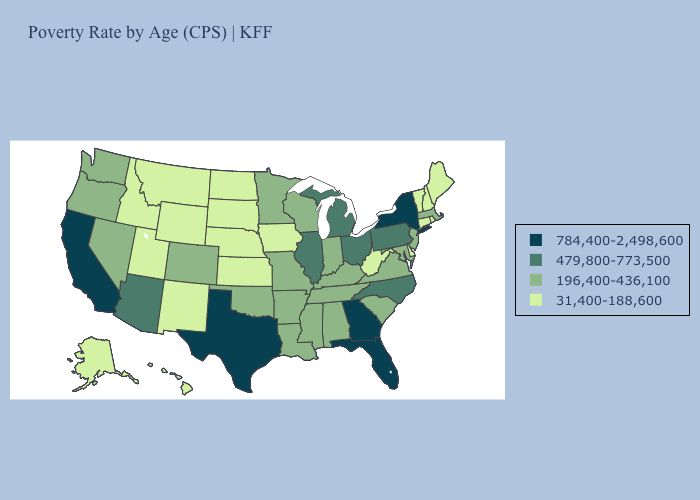Does Pennsylvania have the highest value in the USA?
Answer briefly. No. Among the states that border Massachusetts , does New York have the highest value?
Keep it brief. Yes. Does Missouri have a lower value than New Hampshire?
Short answer required. No. What is the value of Indiana?
Keep it brief. 196,400-436,100. Name the states that have a value in the range 31,400-188,600?
Keep it brief. Alaska, Connecticut, Delaware, Hawaii, Idaho, Iowa, Kansas, Maine, Montana, Nebraska, New Hampshire, New Mexico, North Dakota, Rhode Island, South Dakota, Utah, Vermont, West Virginia, Wyoming. What is the value of Mississippi?
Short answer required. 196,400-436,100. Name the states that have a value in the range 196,400-436,100?
Keep it brief. Alabama, Arkansas, Colorado, Indiana, Kentucky, Louisiana, Maryland, Massachusetts, Minnesota, Mississippi, Missouri, Nevada, New Jersey, Oklahoma, Oregon, South Carolina, Tennessee, Virginia, Washington, Wisconsin. Among the states that border Florida , which have the lowest value?
Keep it brief. Alabama. Does the map have missing data?
Concise answer only. No. Among the states that border Montana , which have the lowest value?
Answer briefly. Idaho, North Dakota, South Dakota, Wyoming. Name the states that have a value in the range 196,400-436,100?
Short answer required. Alabama, Arkansas, Colorado, Indiana, Kentucky, Louisiana, Maryland, Massachusetts, Minnesota, Mississippi, Missouri, Nevada, New Jersey, Oklahoma, Oregon, South Carolina, Tennessee, Virginia, Washington, Wisconsin. What is the highest value in states that border Alabama?
Keep it brief. 784,400-2,498,600. Among the states that border Massachusetts , does New York have the lowest value?
Give a very brief answer. No. What is the value of Virginia?
Be succinct. 196,400-436,100. Among the states that border Pennsylvania , which have the lowest value?
Answer briefly. Delaware, West Virginia. 